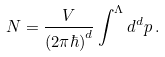Convert formula to latex. <formula><loc_0><loc_0><loc_500><loc_500>N = \frac { V } { ( 2 \pi \hbar { ) } ^ { d } } \int ^ { \Lambda } d ^ { d } p \, .</formula> 